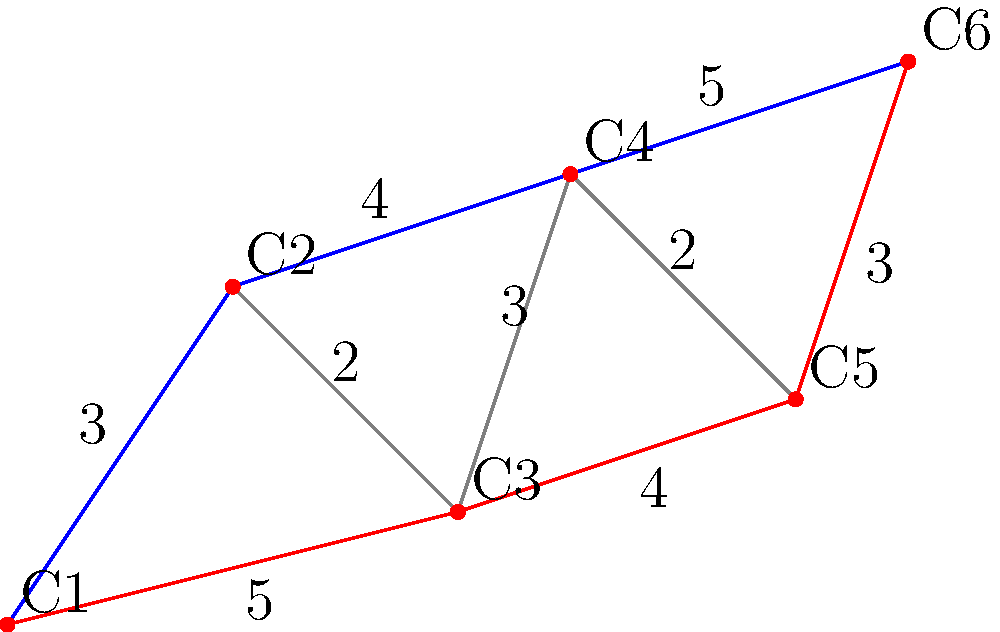A nighttime search and rescue operation requires visiting six checkpoints (C1 to C6) on a topographical map. The distances between connected checkpoints are shown in kilometers. What is the shortest path from C1 to C6, and what is its total distance? To find the shortest path from C1 to C6, we'll use Dijkstra's algorithm:

1. Initialize:
   - C1: 0 (starting point)
   - All other checkpoints: infinity

2. Update neighbors of C1:
   - C2: 3
   - C3: 5

3. Visit C2 (shortest unvisited):
   - Update C3: min(5, 3+2) = 5
   - Update C4: 3+4 = 7

4. Visit C3 (shortest unvisited):
   - Update C4: min(7, 5+3) = 7
   - Update C5: 5+4 = 9

5. Visit C4 (shortest unvisited):
   - Update C5: min(9, 7+2) = 9
   - Update C6: 7+5 = 12

6. Visit C5 (shortest unvisited):
   - Update C6: min(12, 9+3) = 12

7. Visit C6 (destination reached)

The shortest path is C1 -> C2 -> C4 -> C6 with a total distance of 12 km.
Answer: C1 -> C2 -> C4 -> C6, 12 km 